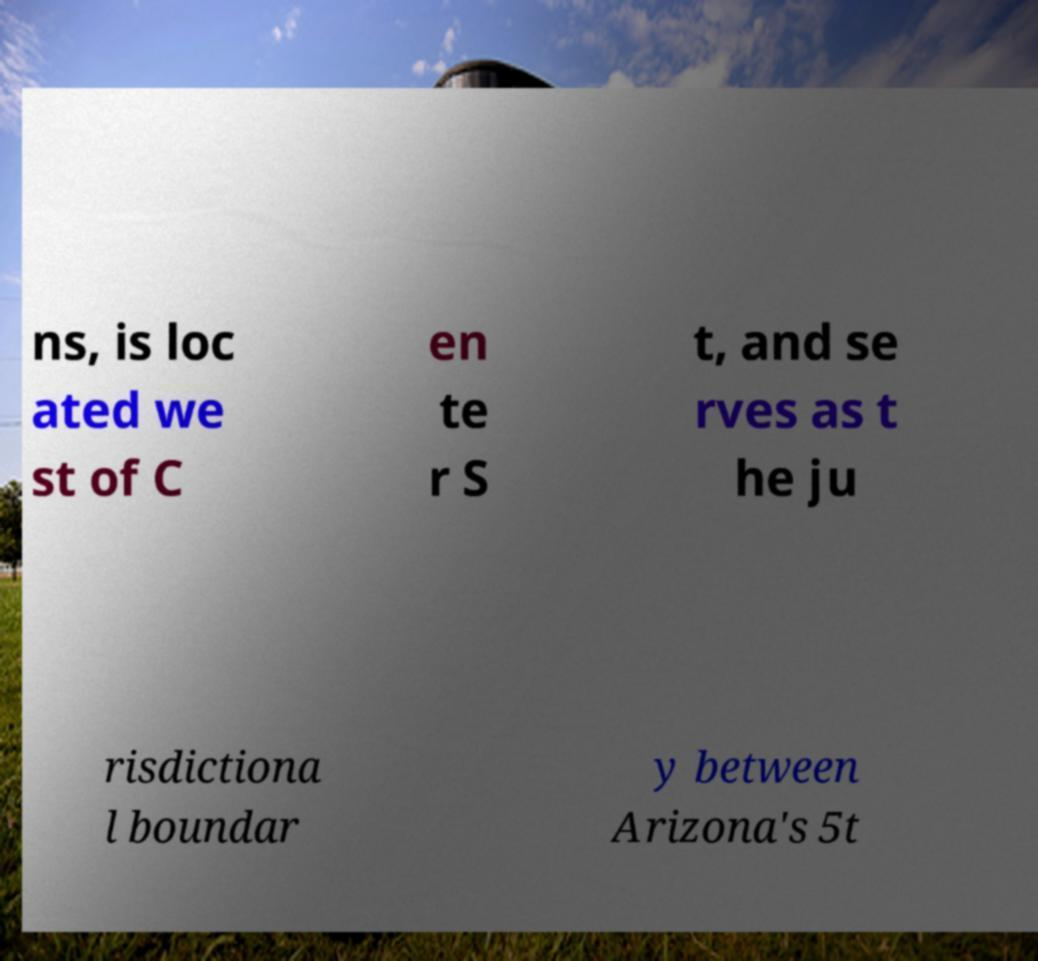I need the written content from this picture converted into text. Can you do that? ns, is loc ated we st of C en te r S t, and se rves as t he ju risdictiona l boundar y between Arizona's 5t 